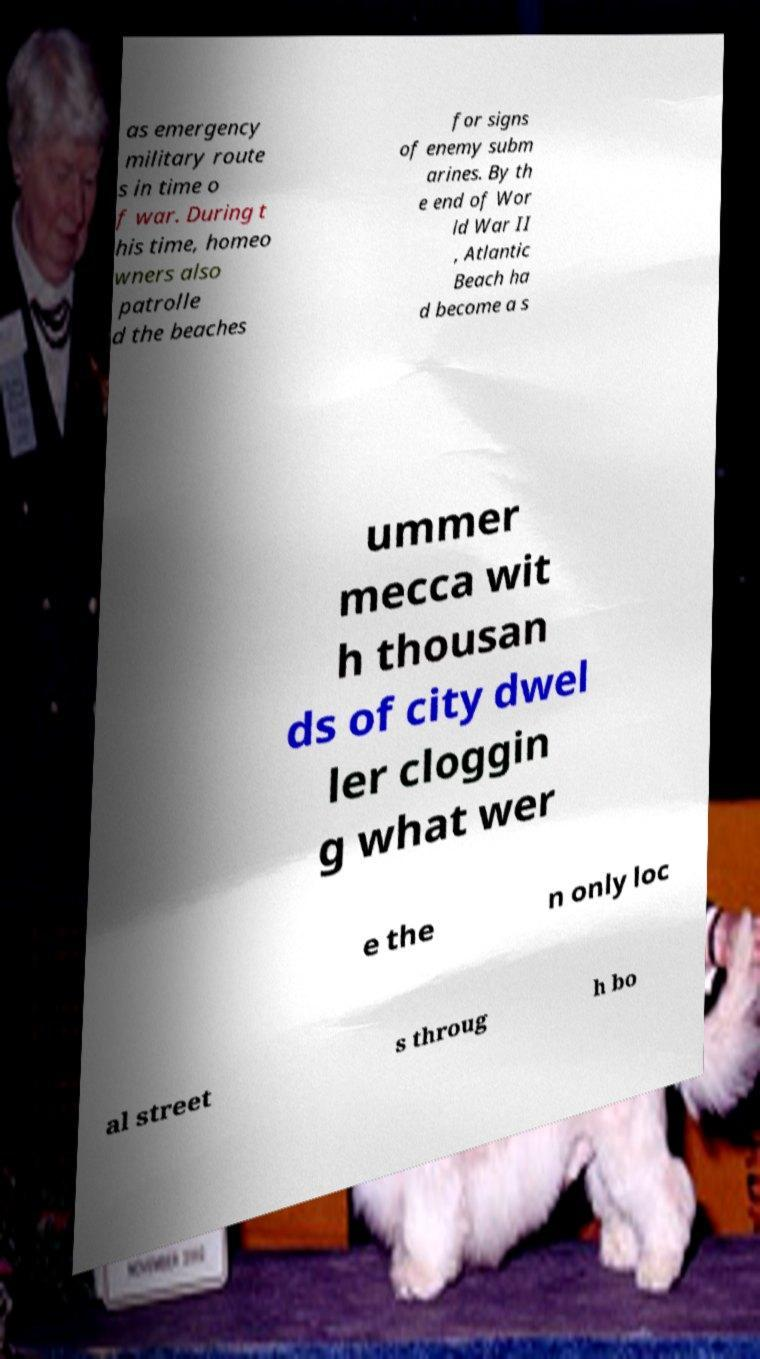What messages or text are displayed in this image? I need them in a readable, typed format. as emergency military route s in time o f war. During t his time, homeo wners also patrolle d the beaches for signs of enemy subm arines. By th e end of Wor ld War II , Atlantic Beach ha d become a s ummer mecca wit h thousan ds of city dwel ler cloggin g what wer e the n only loc al street s throug h bo 